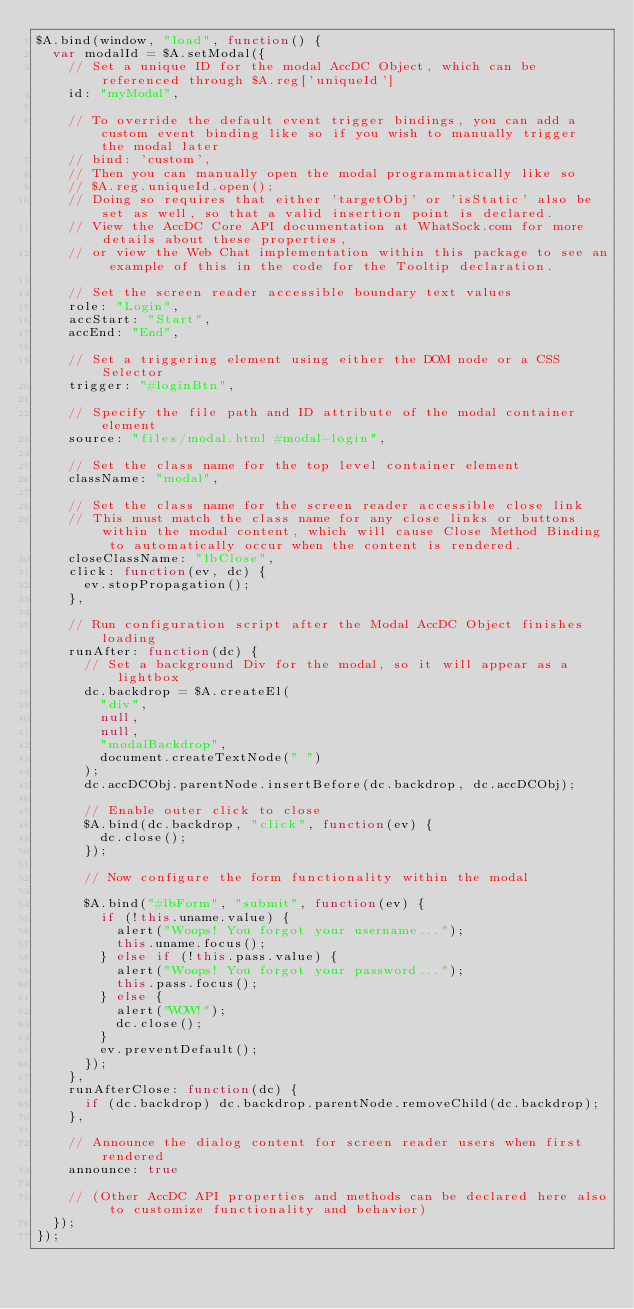<code> <loc_0><loc_0><loc_500><loc_500><_JavaScript_>$A.bind(window, "load", function() {
  var modalId = $A.setModal({
    // Set a unique ID for the modal AccDC Object, which can be referenced through $A.reg['uniqueId']
    id: "myModal",

    // To override the default event trigger bindings, you can add a custom event binding like so if you wish to manually trigger the modal later
    // bind: 'custom',
    // Then you can manually open the modal programmatically like so
    // $A.reg.uniqueId.open();
    // Doing so requires that either 'targetObj' or 'isStatic' also be set as well, so that a valid insertion point is declared.
    // View the AccDC Core API documentation at WhatSock.com for more details about these properties,
    // or view the Web Chat implementation within this package to see an example of this in the code for the Tooltip declaration.

    // Set the screen reader accessible boundary text values
    role: "Login",
    accStart: "Start",
    accEnd: "End",

    // Set a triggering element using either the DOM node or a CSS Selector
    trigger: "#loginBtn",

    // Specify the file path and ID attribute of the modal container element
    source: "files/modal.html #modal-login",

    // Set the class name for the top level container element
    className: "modal",

    // Set the class name for the screen reader accessible close link
    // This must match the class name for any close links or buttons within the modal content, which will cause Close Method Binding to automatically occur when the content is rendered.
    closeClassName: "lbClose",
    click: function(ev, dc) {
      ev.stopPropagation();
    },

    // Run configuration script after the Modal AccDC Object finishes loading
    runAfter: function(dc) {
      // Set a background Div for the modal, so it will appear as a lightbox
      dc.backdrop = $A.createEl(
        "div",
        null,
        null,
        "modalBackdrop",
        document.createTextNode(" ")
      );
      dc.accDCObj.parentNode.insertBefore(dc.backdrop, dc.accDCObj);

      // Enable outer click to close
      $A.bind(dc.backdrop, "click", function(ev) {
        dc.close();
      });

      // Now configure the form functionality within the modal

      $A.bind("#lbForm", "submit", function(ev) {
        if (!this.uname.value) {
          alert("Woops! You forgot your username...");
          this.uname.focus();
        } else if (!this.pass.value) {
          alert("Woops! You forgot your password...");
          this.pass.focus();
        } else {
          alert("WOW!");
          dc.close();
        }
        ev.preventDefault();
      });
    },
    runAfterClose: function(dc) {
      if (dc.backdrop) dc.backdrop.parentNode.removeChild(dc.backdrop);
    },

    // Announce the dialog content for screen reader users when first rendered
    announce: true

    // (Other AccDC API properties and methods can be declared here also to customize functionality and behavior)
  });
});
</code> 